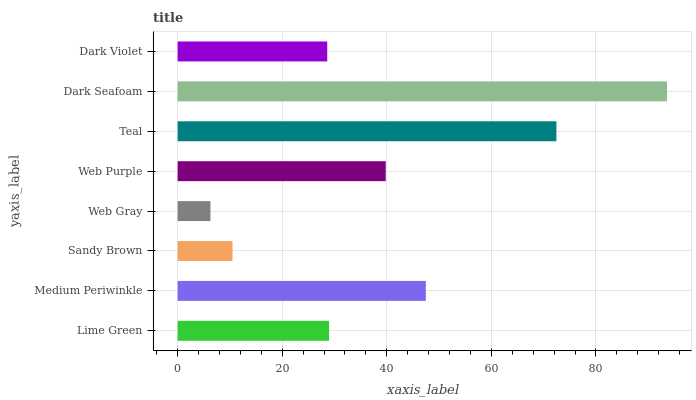Is Web Gray the minimum?
Answer yes or no. Yes. Is Dark Seafoam the maximum?
Answer yes or no. Yes. Is Medium Periwinkle the minimum?
Answer yes or no. No. Is Medium Periwinkle the maximum?
Answer yes or no. No. Is Medium Periwinkle greater than Lime Green?
Answer yes or no. Yes. Is Lime Green less than Medium Periwinkle?
Answer yes or no. Yes. Is Lime Green greater than Medium Periwinkle?
Answer yes or no. No. Is Medium Periwinkle less than Lime Green?
Answer yes or no. No. Is Web Purple the high median?
Answer yes or no. Yes. Is Lime Green the low median?
Answer yes or no. Yes. Is Web Gray the high median?
Answer yes or no. No. Is Dark Violet the low median?
Answer yes or no. No. 